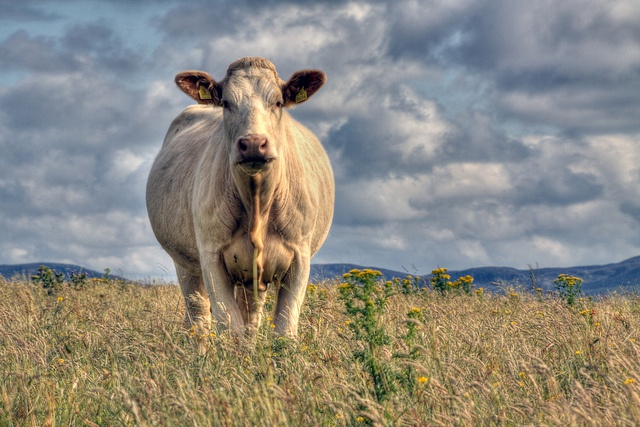Describe the objects in this image and their specific colors. I can see a cow in gray and tan tones in this image. 